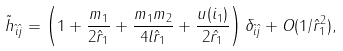<formula> <loc_0><loc_0><loc_500><loc_500>\tilde { h } _ { \hat { i } \hat { j } } = \left ( 1 + \frac { m _ { 1 } } { 2 \hat { r } _ { 1 } } + \frac { m _ { 1 } m _ { 2 } } { 4 l \hat { r } _ { 1 } } + \frac { u ( i _ { 1 } ) } { 2 \hat { r _ { 1 } } } \right ) \delta _ { \hat { i } \hat { j } } + O ( 1 / \hat { r } ^ { 2 } _ { 1 } ) ,</formula> 